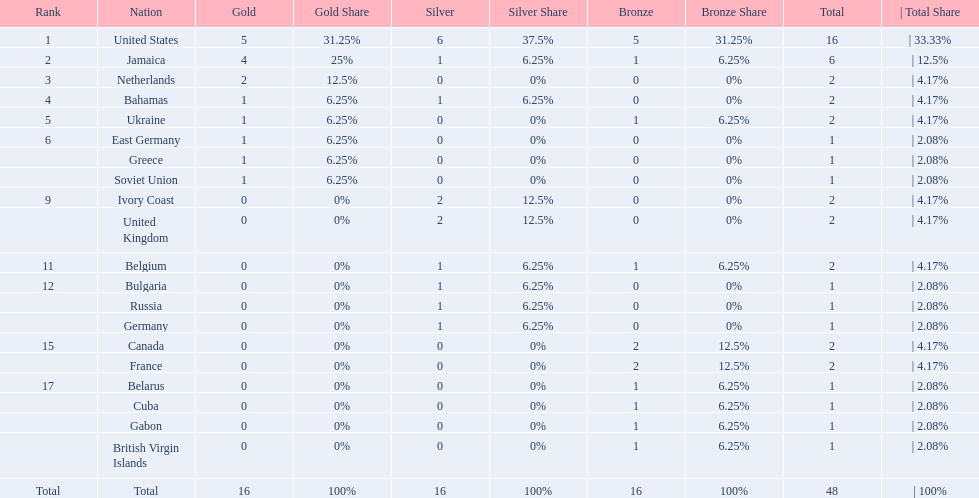Which nations took home at least one gold medal in the 60 metres competition? United States, Jamaica, Netherlands, Bahamas, Ukraine, East Germany, Greece, Soviet Union. Of these nations, which one won the most gold medals? United States. 